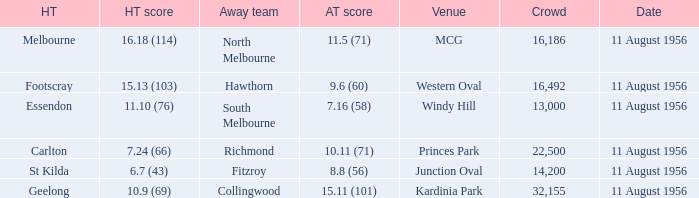What is the home team score for Footscray? 15.13 (103). 